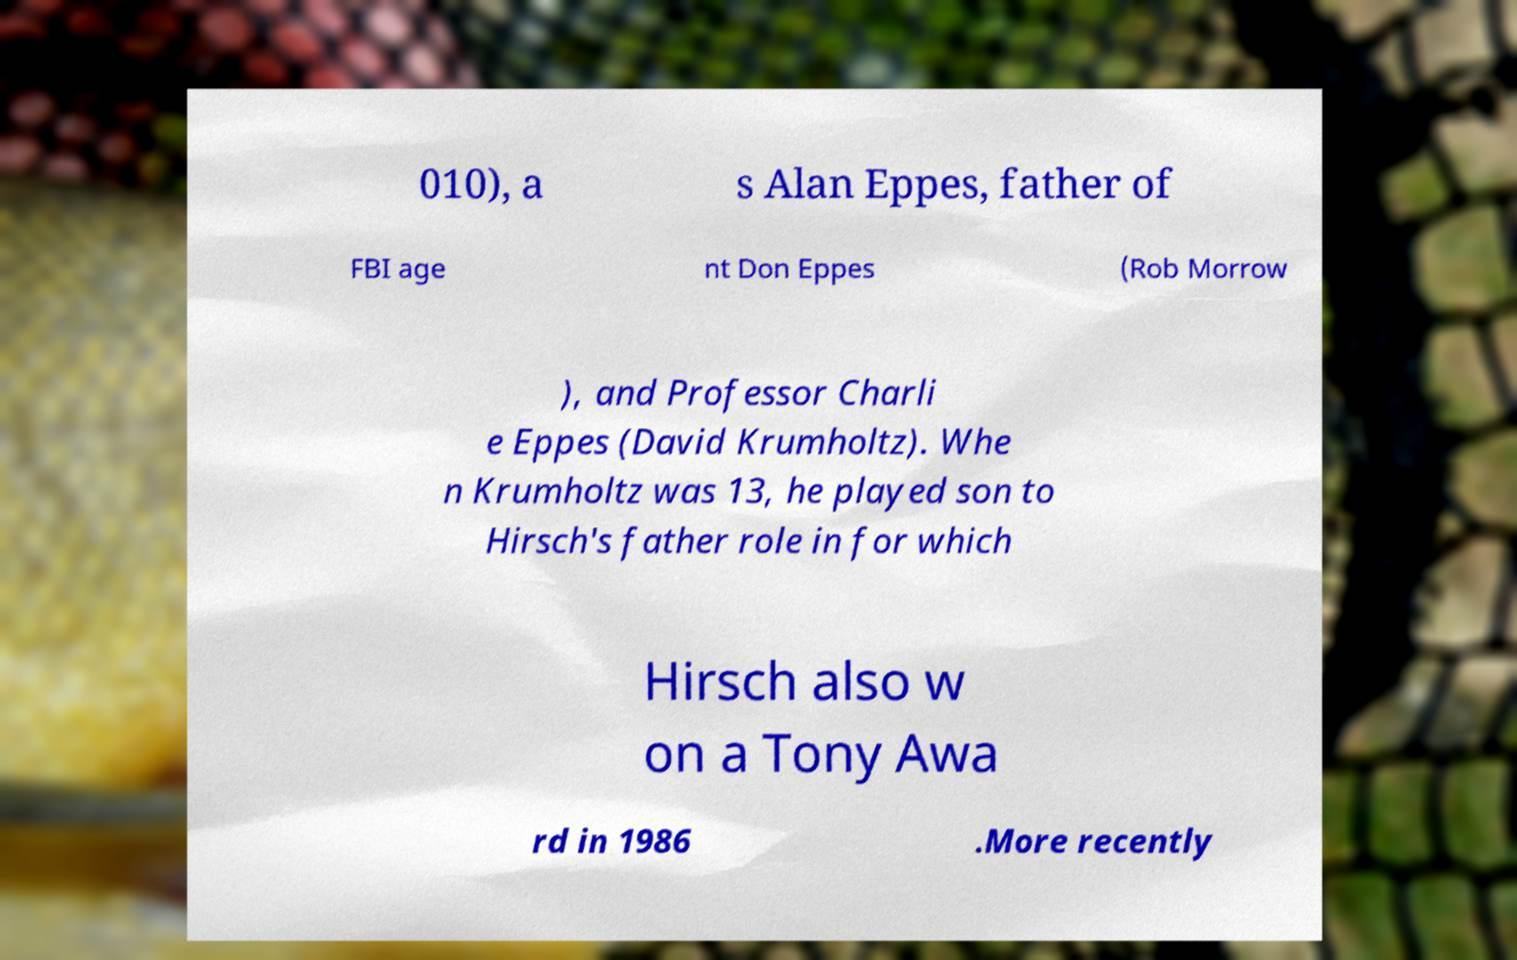Please identify and transcribe the text found in this image. 010), a s Alan Eppes, father of FBI age nt Don Eppes (Rob Morrow ), and Professor Charli e Eppes (David Krumholtz). Whe n Krumholtz was 13, he played son to Hirsch's father role in for which Hirsch also w on a Tony Awa rd in 1986 .More recently 